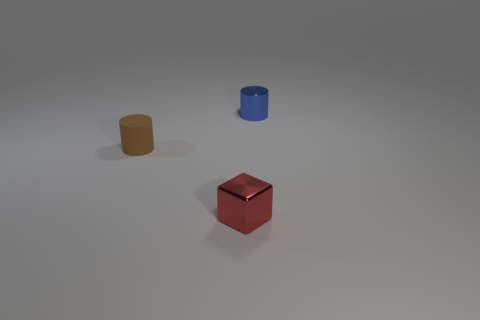Is there anything else that has the same material as the brown cylinder?
Offer a very short reply. No. What number of blue cylinders have the same material as the block?
Your answer should be compact. 1. There is a cube that is made of the same material as the blue object; what color is it?
Your answer should be very brief. Red. Are there fewer small red metallic things than cylinders?
Offer a very short reply. Yes. There is another thing that is the same shape as the small blue shiny object; what color is it?
Your answer should be very brief. Brown. There is a object that is to the left of the small metal thing that is in front of the tiny blue thing; is there a rubber thing that is on the left side of it?
Ensure brevity in your answer.  No. Is the shape of the tiny blue shiny object the same as the tiny red thing?
Ensure brevity in your answer.  No. Is the number of small red blocks in front of the small red metal cube less than the number of tiny shiny cubes?
Provide a succinct answer. Yes. What color is the small cylinder to the right of the red block in front of the tiny cylinder to the right of the red shiny object?
Offer a very short reply. Blue. How many rubber objects are either blue cylinders or tiny brown things?
Make the answer very short. 1. 